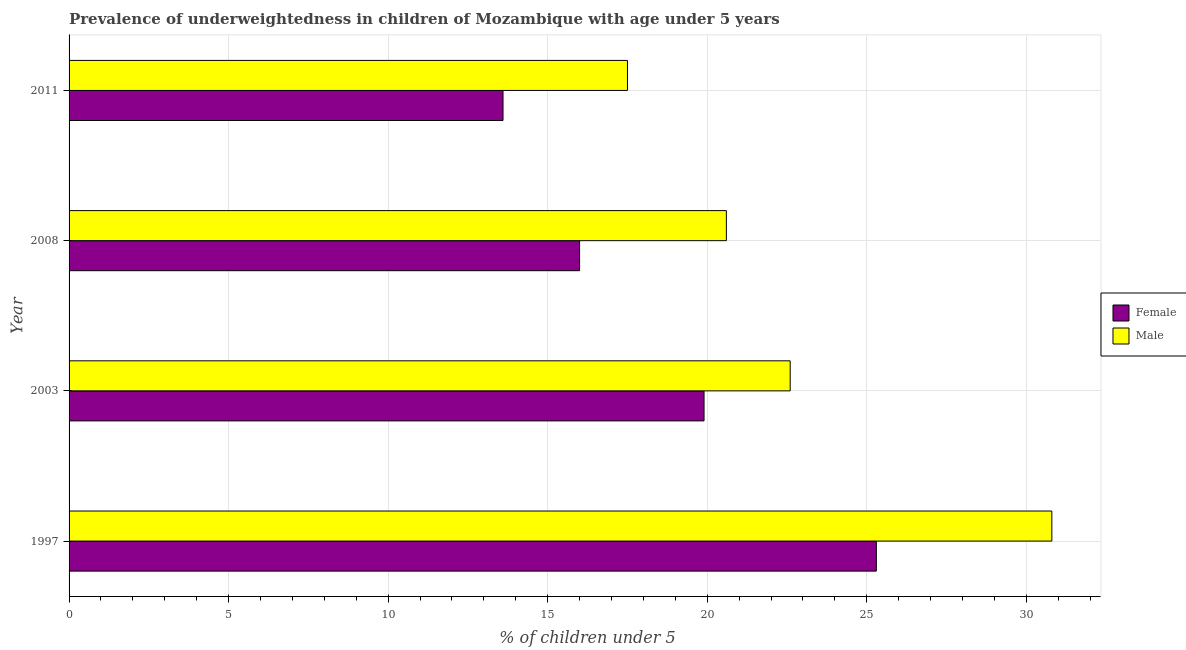Are the number of bars per tick equal to the number of legend labels?
Offer a terse response. Yes. How many bars are there on the 3rd tick from the top?
Provide a succinct answer. 2. How many bars are there on the 1st tick from the bottom?
Make the answer very short. 2. What is the label of the 1st group of bars from the top?
Ensure brevity in your answer.  2011. In how many cases, is the number of bars for a given year not equal to the number of legend labels?
Provide a short and direct response. 0. What is the percentage of underweighted female children in 1997?
Your answer should be very brief. 25.3. Across all years, what is the maximum percentage of underweighted male children?
Ensure brevity in your answer.  30.8. Across all years, what is the minimum percentage of underweighted male children?
Make the answer very short. 17.5. In which year was the percentage of underweighted male children maximum?
Give a very brief answer. 1997. In which year was the percentage of underweighted female children minimum?
Your answer should be very brief. 2011. What is the total percentage of underweighted male children in the graph?
Offer a very short reply. 91.5. What is the difference between the percentage of underweighted male children in 2008 and the percentage of underweighted female children in 2011?
Provide a succinct answer. 7. In how many years, is the percentage of underweighted male children greater than 14 %?
Provide a succinct answer. 4. What is the ratio of the percentage of underweighted female children in 2008 to that in 2011?
Provide a short and direct response. 1.18. Is the percentage of underweighted female children in 1997 less than that in 2011?
Offer a terse response. No. Is the difference between the percentage of underweighted female children in 1997 and 2008 greater than the difference between the percentage of underweighted male children in 1997 and 2008?
Offer a very short reply. No. What is the difference between the highest and the lowest percentage of underweighted female children?
Ensure brevity in your answer.  11.7. In how many years, is the percentage of underweighted male children greater than the average percentage of underweighted male children taken over all years?
Provide a succinct answer. 1. Is the sum of the percentage of underweighted female children in 2003 and 2008 greater than the maximum percentage of underweighted male children across all years?
Your answer should be compact. Yes. What does the 1st bar from the top in 2011 represents?
Your answer should be very brief. Male. What does the 1st bar from the bottom in 2003 represents?
Provide a succinct answer. Female. How many bars are there?
Make the answer very short. 8. Are the values on the major ticks of X-axis written in scientific E-notation?
Keep it short and to the point. No. Where does the legend appear in the graph?
Provide a succinct answer. Center right. How are the legend labels stacked?
Keep it short and to the point. Vertical. What is the title of the graph?
Provide a succinct answer. Prevalence of underweightedness in children of Mozambique with age under 5 years. Does "Gasoline" appear as one of the legend labels in the graph?
Provide a short and direct response. No. What is the label or title of the X-axis?
Provide a succinct answer.  % of children under 5. What is the label or title of the Y-axis?
Keep it short and to the point. Year. What is the  % of children under 5 of Female in 1997?
Provide a short and direct response. 25.3. What is the  % of children under 5 of Male in 1997?
Ensure brevity in your answer.  30.8. What is the  % of children under 5 of Female in 2003?
Your answer should be very brief. 19.9. What is the  % of children under 5 of Male in 2003?
Keep it short and to the point. 22.6. What is the  % of children under 5 in Male in 2008?
Offer a terse response. 20.6. What is the  % of children under 5 in Female in 2011?
Provide a short and direct response. 13.6. Across all years, what is the maximum  % of children under 5 of Female?
Ensure brevity in your answer.  25.3. Across all years, what is the maximum  % of children under 5 of Male?
Give a very brief answer. 30.8. Across all years, what is the minimum  % of children under 5 in Female?
Ensure brevity in your answer.  13.6. What is the total  % of children under 5 in Female in the graph?
Give a very brief answer. 74.8. What is the total  % of children under 5 of Male in the graph?
Provide a succinct answer. 91.5. What is the difference between the  % of children under 5 of Female in 1997 and that in 2003?
Give a very brief answer. 5.4. What is the difference between the  % of children under 5 in Male in 1997 and that in 2011?
Make the answer very short. 13.3. What is the difference between the  % of children under 5 in Male in 2003 and that in 2008?
Your answer should be compact. 2. What is the difference between the  % of children under 5 in Female in 2003 and that in 2011?
Your answer should be compact. 6.3. What is the difference between the  % of children under 5 of Male in 2003 and that in 2011?
Offer a very short reply. 5.1. What is the difference between the  % of children under 5 of Female in 2008 and that in 2011?
Offer a very short reply. 2.4. What is the difference between the  % of children under 5 in Male in 2008 and that in 2011?
Ensure brevity in your answer.  3.1. What is the difference between the  % of children under 5 in Female in 1997 and the  % of children under 5 in Male in 2008?
Provide a succinct answer. 4.7. What is the difference between the  % of children under 5 of Female in 2003 and the  % of children under 5 of Male in 2008?
Make the answer very short. -0.7. What is the difference between the  % of children under 5 in Female in 2003 and the  % of children under 5 in Male in 2011?
Offer a very short reply. 2.4. What is the average  % of children under 5 in Female per year?
Provide a succinct answer. 18.7. What is the average  % of children under 5 of Male per year?
Make the answer very short. 22.88. In the year 1997, what is the difference between the  % of children under 5 of Female and  % of children under 5 of Male?
Keep it short and to the point. -5.5. What is the ratio of the  % of children under 5 of Female in 1997 to that in 2003?
Your response must be concise. 1.27. What is the ratio of the  % of children under 5 in Male in 1997 to that in 2003?
Provide a succinct answer. 1.36. What is the ratio of the  % of children under 5 of Female in 1997 to that in 2008?
Your answer should be compact. 1.58. What is the ratio of the  % of children under 5 in Male in 1997 to that in 2008?
Your answer should be compact. 1.5. What is the ratio of the  % of children under 5 of Female in 1997 to that in 2011?
Keep it short and to the point. 1.86. What is the ratio of the  % of children under 5 in Male in 1997 to that in 2011?
Ensure brevity in your answer.  1.76. What is the ratio of the  % of children under 5 in Female in 2003 to that in 2008?
Provide a short and direct response. 1.24. What is the ratio of the  % of children under 5 in Male in 2003 to that in 2008?
Provide a succinct answer. 1.1. What is the ratio of the  % of children under 5 in Female in 2003 to that in 2011?
Give a very brief answer. 1.46. What is the ratio of the  % of children under 5 in Male in 2003 to that in 2011?
Keep it short and to the point. 1.29. What is the ratio of the  % of children under 5 of Female in 2008 to that in 2011?
Ensure brevity in your answer.  1.18. What is the ratio of the  % of children under 5 in Male in 2008 to that in 2011?
Your answer should be compact. 1.18. What is the difference between the highest and the second highest  % of children under 5 in Female?
Keep it short and to the point. 5.4. 